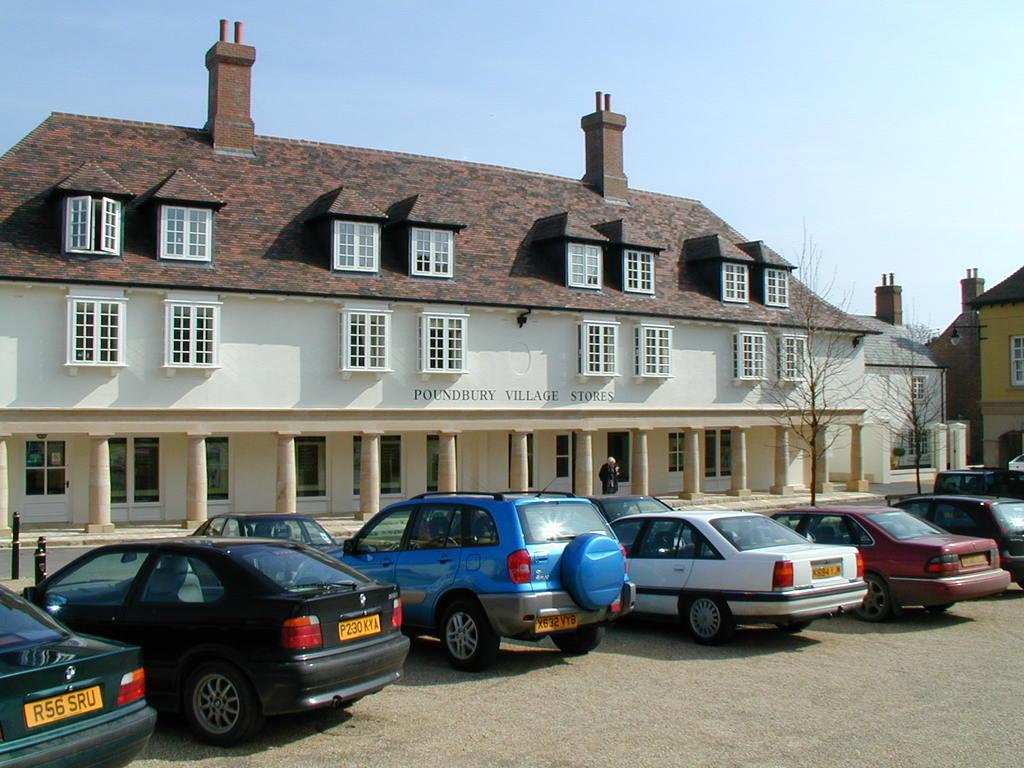What type of vehicles can be seen in the front of the image? There are cars in the front of the image. What structures are visible in the background of the image? There are buildings in the background of the image. What type of vegetation can be seen in the image? There are trees visible in the image. What is the main subject in the middle of the image? There is a person in the middle of the image. What is visible at the top of the image? The sky is visible at the top of the image. Can you see any icicles hanging from the buildings in the image? There are no icicles visible in the image. What type of cannon is present in the image? There is no cannon present in the image. 